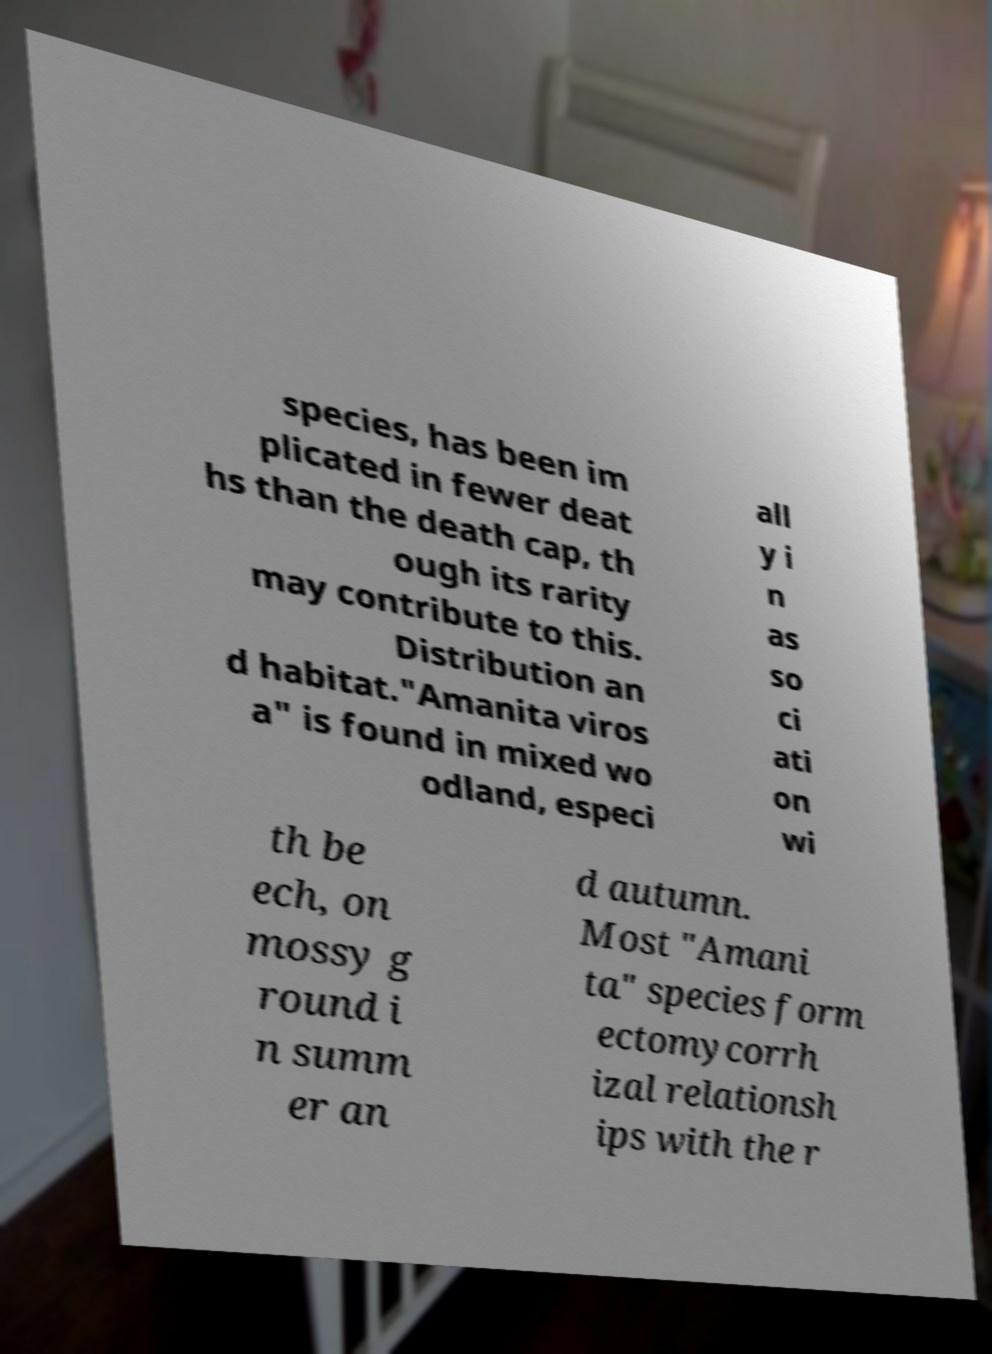I need the written content from this picture converted into text. Can you do that? species, has been im plicated in fewer deat hs than the death cap, th ough its rarity may contribute to this. Distribution an d habitat."Amanita viros a" is found in mixed wo odland, especi all y i n as so ci ati on wi th be ech, on mossy g round i n summ er an d autumn. Most "Amani ta" species form ectomycorrh izal relationsh ips with the r 